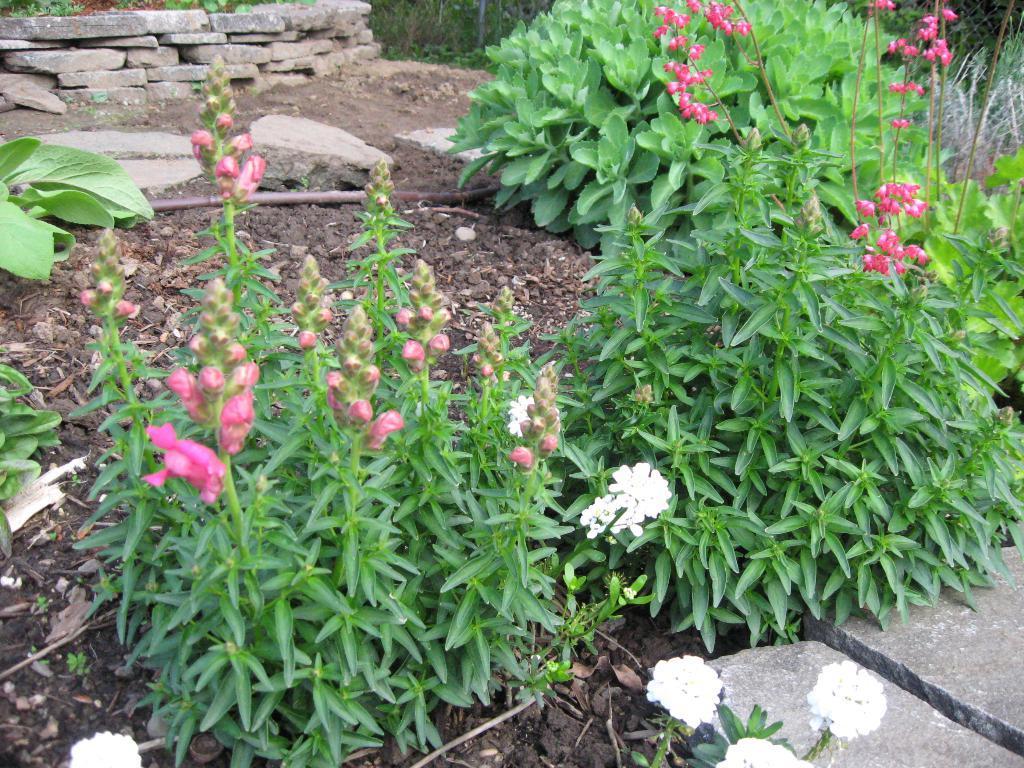Describe this image in one or two sentences. In the image we can see plants and flowers, pink and white in colors. Here we can see the soil, wooden pieces and stones. 